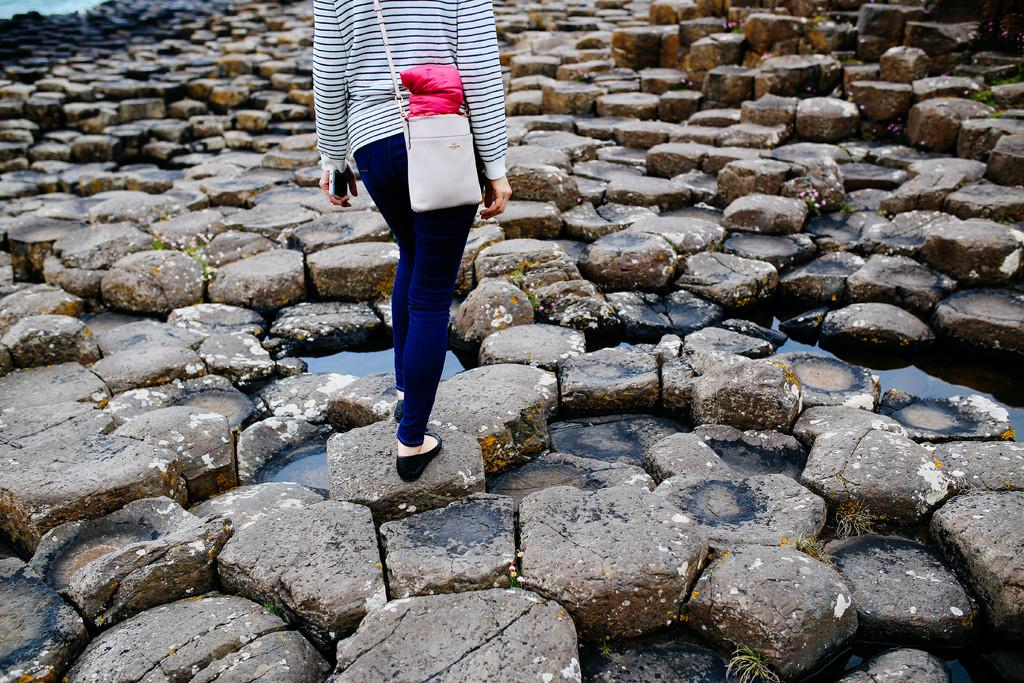What is the person in the image doing? There is a person standing in the image. What is the person carrying? The person is carrying a bag. What type of natural elements can be seen in the image? There are stones, water, and grass visible in the image. What type of debt is the person discussing with the stones in the image? There is no indication of a debt or any discussion in the image; it simply shows a person standing with a bag, stones, water, and grass visible. 